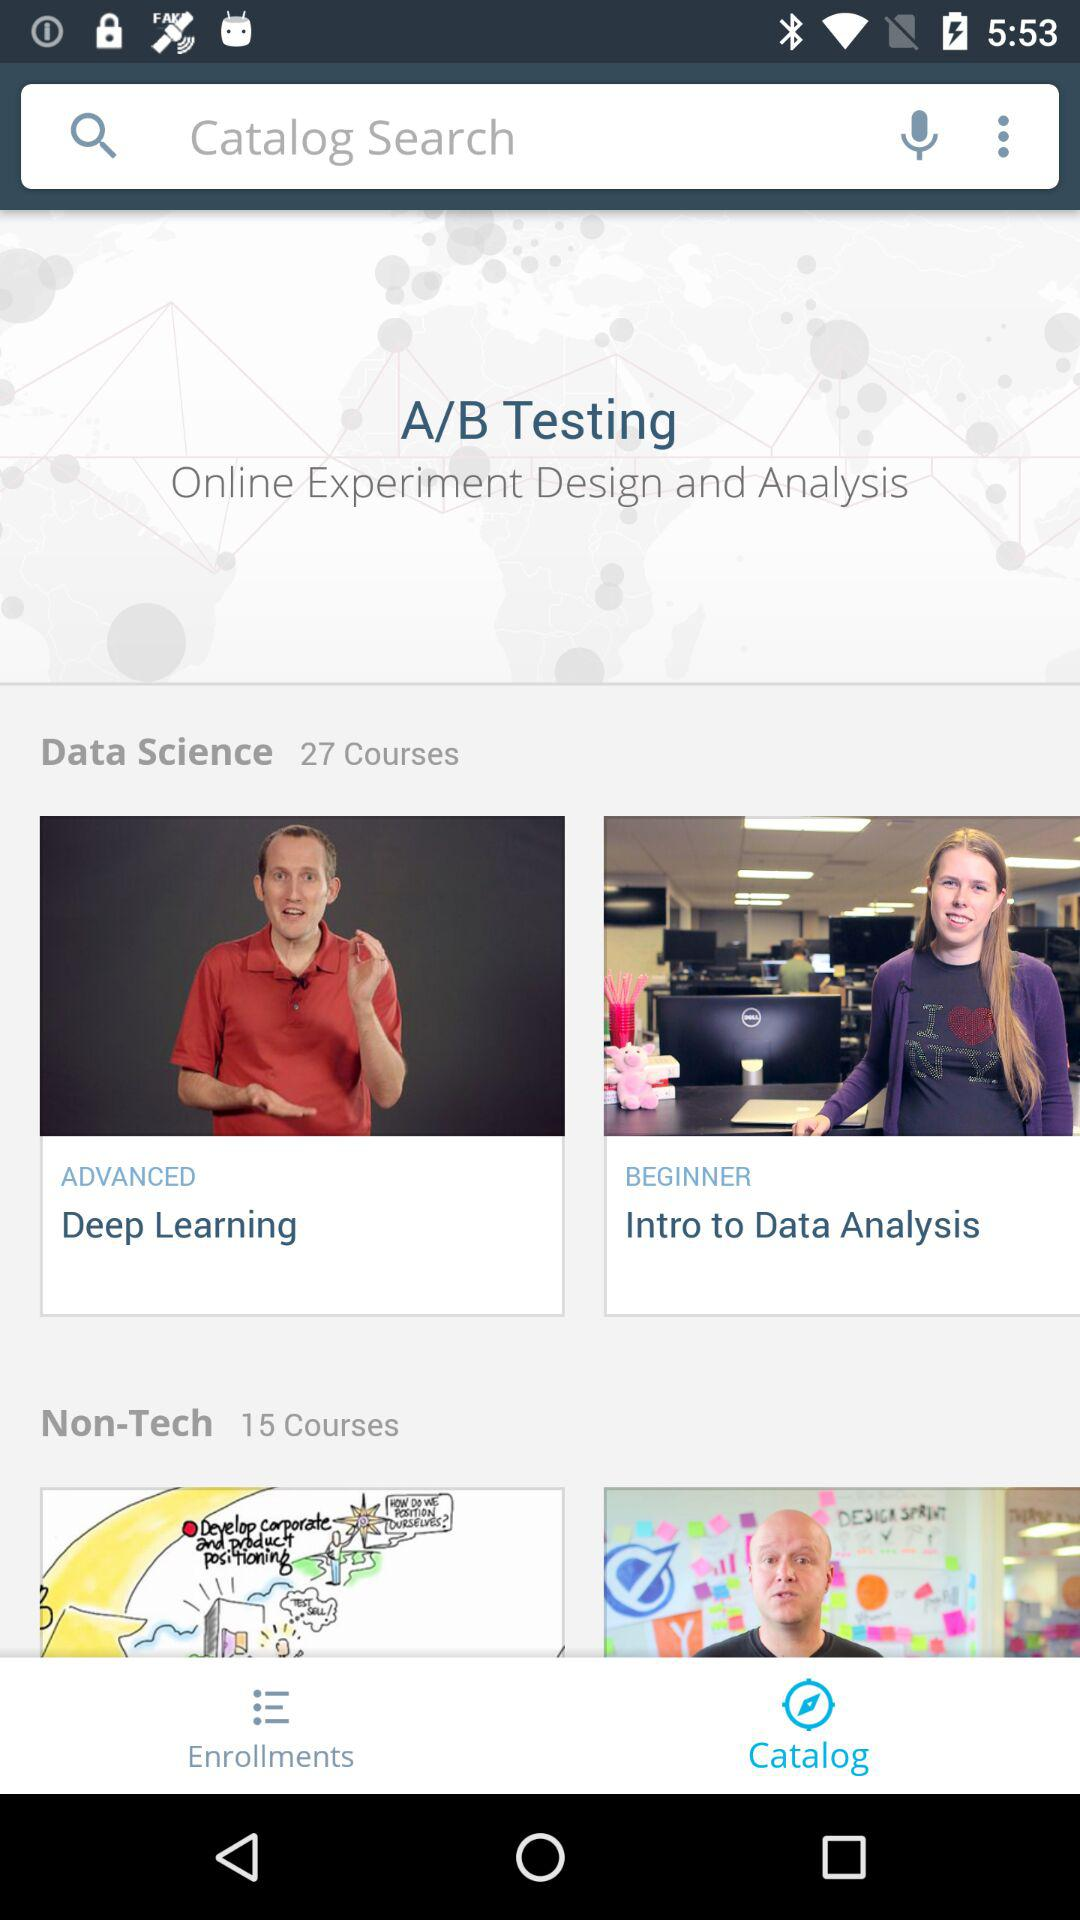What is the name of the advanced data science course? The name of the advanced data science course is "Deep Learning". 